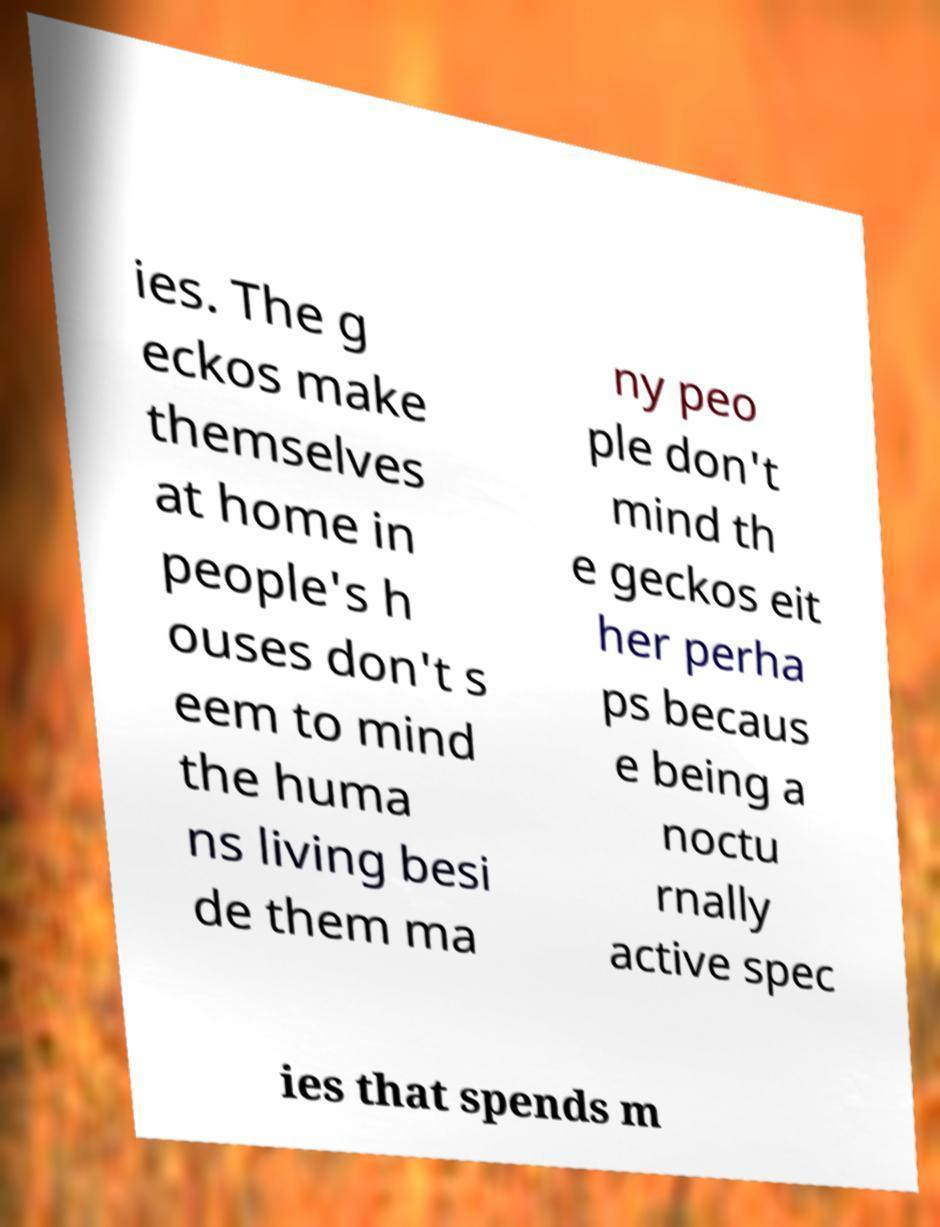For documentation purposes, I need the text within this image transcribed. Could you provide that? ies. The g eckos make themselves at home in people's h ouses don't s eem to mind the huma ns living besi de them ma ny peo ple don't mind th e geckos eit her perha ps becaus e being a noctu rnally active spec ies that spends m 